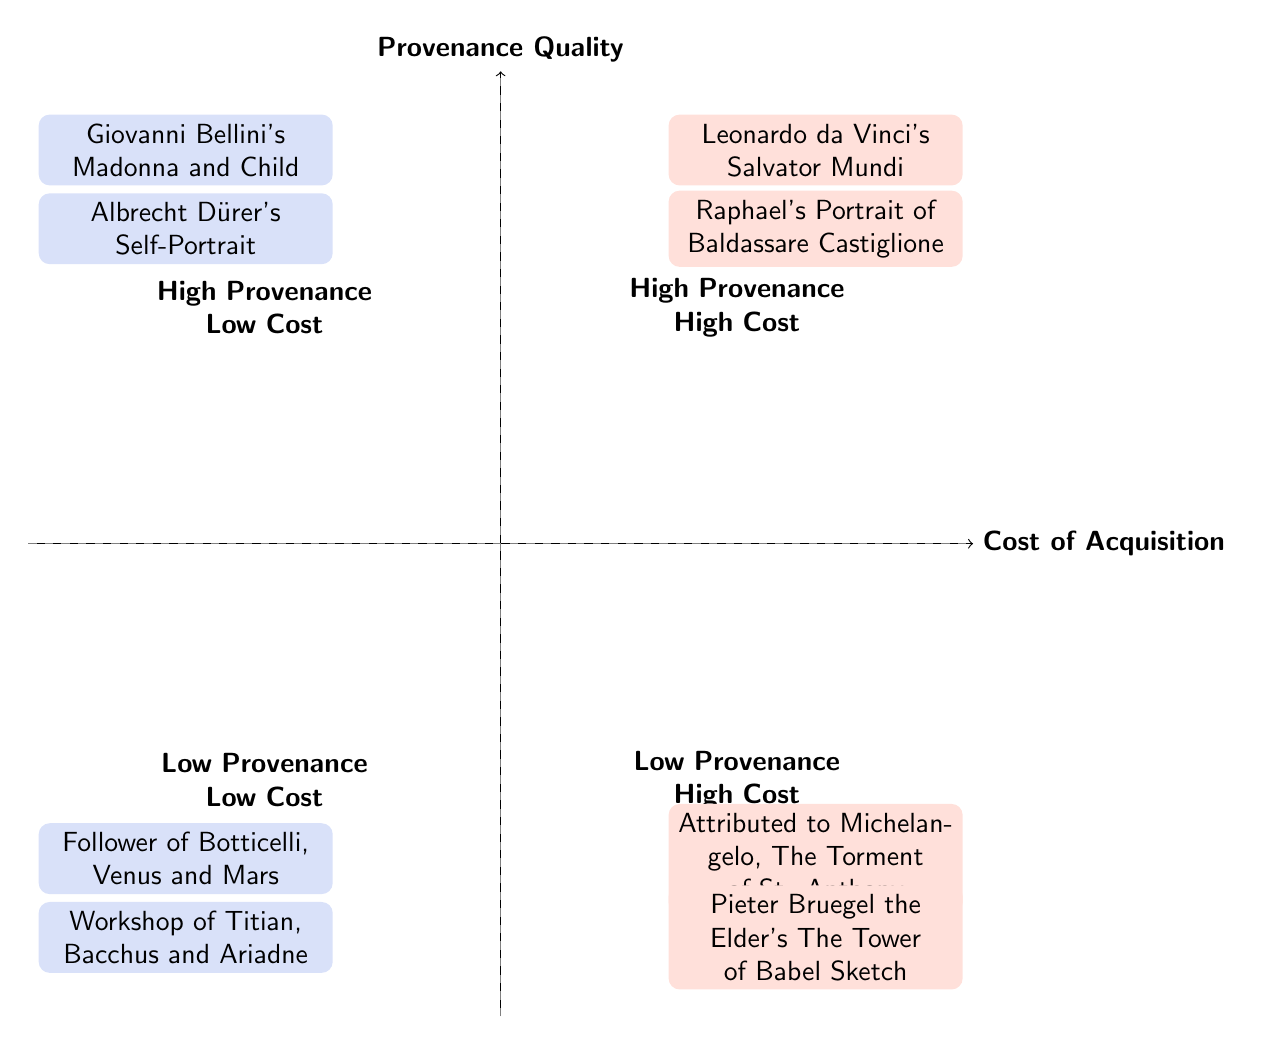What are the two artworks listed in the high provenance, high cost quadrant? In the diagram, the quadrant labeled "High Provenance High Cost" includes two artworks: "Leonardo da Vinci's Salvator Mundi" and "Raphael's Portrait of Baldassare Castiglione".
Answer: Leonardo da Vinci's Salvator Mundi, Raphael's Portrait of Baldassare Castiglione How many artworks are placed in the low provenance, low cost quadrant? The quadrant labeled "Low Provenance Low Cost" contains two artworks: "Follower of Botticelli, Venus and Mars" and "Workshop of Titian, Bacchus and Ariadne".
Answer: 2 Which artwork has been attributed to Michelangelo in the low provenance, high cost quadrant? In the "Low Provenance High Cost" quadrant, the artwork listed as attributed to Michelangelo is "The Torment of St. Anthony".
Answer: The Torment of St. Anthony What is the provenance quality and cost status of Giovanni Bellini's Madonna and Child? "Giovanni Bellini's Madonna and Child" is categorized in the "High Provenance Low Cost" quadrant, indicating it has high provenance quality and low cost of acquisition.
Answer: High Provenance Low Cost Which two artworks are in the high provenance, low cost quadrant? The "High Provenance Low Cost" quadrant contains "Giovanni Bellini's Madonna and Child" and "Albrecht Dürer's Self-Portrait".
Answer: Giovanni Bellini's Madonna and Child, Albrecht Dürer's Self-Portrait What can you infer about artworks in the high provenance, high cost quadrant compared to the low provenance, high cost quadrant? Artworks in the "High Provenance High Cost" quadrant have authentication by multiple experts and well-documented provenance, while those in "Low Provenance High Cost" lack definitive proof of authenticity despite high public interest.
Answer: They have better authentication and provenance Which quadrant has artworks that lack substantial provenance? The "Low Provenance Low Cost" quadrant contains artworks that lack substantial provenance, as indicated by their descriptions.
Answer: Low Provenance Low Cost 